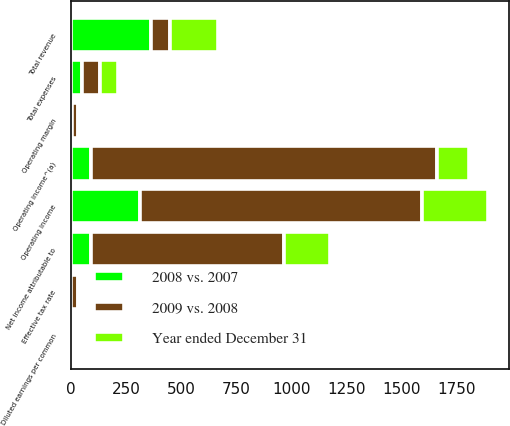<chart> <loc_0><loc_0><loc_500><loc_500><stacked_bar_chart><ecel><fcel>Total revenue<fcel>Total expenses<fcel>Operating income<fcel>Operating margin<fcel>Net income attributable to<fcel>Diluted earnings per common<fcel>Effective tax rate<fcel>Operating income^(a)<nl><fcel>2009 vs. 2008<fcel>85.5<fcel>85.5<fcel>1278<fcel>27.2<fcel>875<fcel>6.11<fcel>30<fcel>1570<nl><fcel>2008 vs. 2007<fcel>364<fcel>49<fcel>315<fcel>4.3<fcel>91<fcel>0.33<fcel>3<fcel>92<nl><fcel>Year ended December 31<fcel>219<fcel>80<fcel>299<fcel>4.8<fcel>209<fcel>1.59<fcel>1.2<fcel>144<nl></chart> 